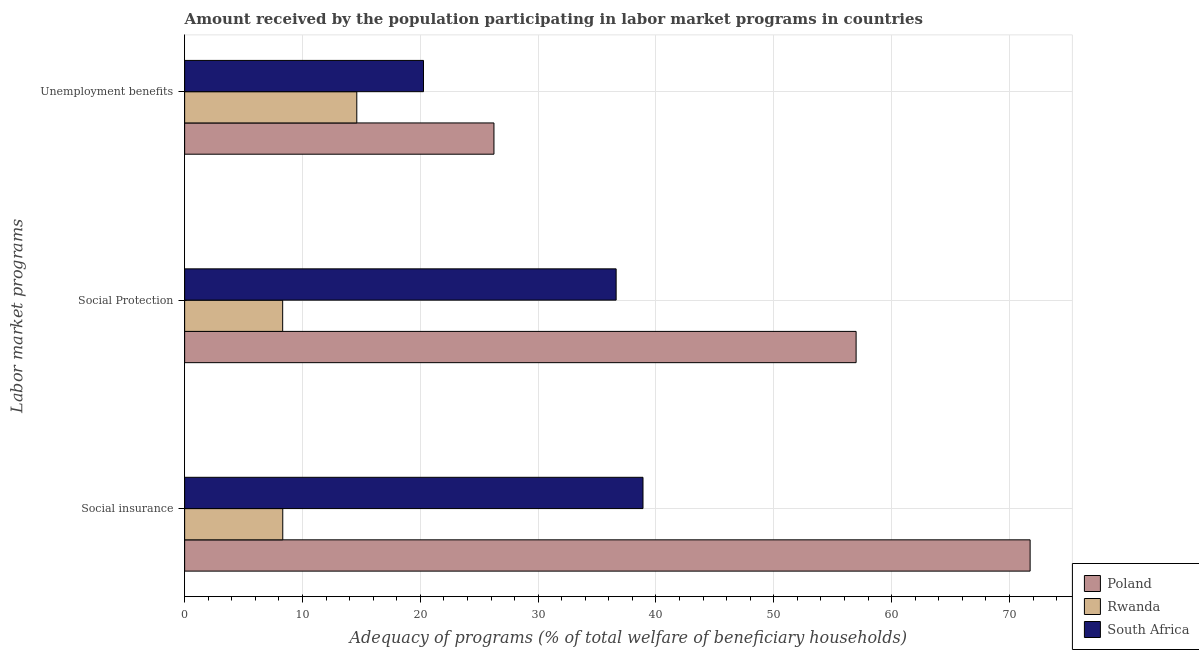Are the number of bars per tick equal to the number of legend labels?
Your response must be concise. Yes. Are the number of bars on each tick of the Y-axis equal?
Your response must be concise. Yes. What is the label of the 2nd group of bars from the top?
Provide a succinct answer. Social Protection. What is the amount received by the population participating in social insurance programs in South Africa?
Make the answer very short. 38.9. Across all countries, what is the maximum amount received by the population participating in unemployment benefits programs?
Ensure brevity in your answer.  26.25. Across all countries, what is the minimum amount received by the population participating in social protection programs?
Your response must be concise. 8.32. In which country was the amount received by the population participating in unemployment benefits programs maximum?
Offer a terse response. Poland. In which country was the amount received by the population participating in social insurance programs minimum?
Keep it short and to the point. Rwanda. What is the total amount received by the population participating in social insurance programs in the graph?
Give a very brief answer. 118.98. What is the difference between the amount received by the population participating in social insurance programs in South Africa and that in Poland?
Your answer should be very brief. -32.85. What is the difference between the amount received by the population participating in social insurance programs in Poland and the amount received by the population participating in social protection programs in South Africa?
Offer a very short reply. 35.13. What is the average amount received by the population participating in unemployment benefits programs per country?
Make the answer very short. 20.38. What is the difference between the amount received by the population participating in social protection programs and amount received by the population participating in unemployment benefits programs in South Africa?
Your answer should be very brief. 16.35. In how many countries, is the amount received by the population participating in social insurance programs greater than 24 %?
Your response must be concise. 2. What is the ratio of the amount received by the population participating in social insurance programs in South Africa to that in Rwanda?
Keep it short and to the point. 4.67. Is the amount received by the population participating in social protection programs in Poland less than that in Rwanda?
Your answer should be compact. No. What is the difference between the highest and the second highest amount received by the population participating in social protection programs?
Make the answer very short. 20.36. What is the difference between the highest and the lowest amount received by the population participating in social protection programs?
Ensure brevity in your answer.  48.67. In how many countries, is the amount received by the population participating in social insurance programs greater than the average amount received by the population participating in social insurance programs taken over all countries?
Make the answer very short. 1. Is the sum of the amount received by the population participating in unemployment benefits programs in Poland and South Africa greater than the maximum amount received by the population participating in social insurance programs across all countries?
Your response must be concise. No. What does the 1st bar from the top in Social Protection represents?
Offer a terse response. South Africa. Are the values on the major ticks of X-axis written in scientific E-notation?
Your answer should be very brief. No. What is the title of the graph?
Your answer should be compact. Amount received by the population participating in labor market programs in countries. Does "Bhutan" appear as one of the legend labels in the graph?
Keep it short and to the point. No. What is the label or title of the X-axis?
Make the answer very short. Adequacy of programs (% of total welfare of beneficiary households). What is the label or title of the Y-axis?
Keep it short and to the point. Labor market programs. What is the Adequacy of programs (% of total welfare of beneficiary households) of Poland in Social insurance?
Offer a very short reply. 71.75. What is the Adequacy of programs (% of total welfare of beneficiary households) in Rwanda in Social insurance?
Ensure brevity in your answer.  8.33. What is the Adequacy of programs (% of total welfare of beneficiary households) in South Africa in Social insurance?
Give a very brief answer. 38.9. What is the Adequacy of programs (% of total welfare of beneficiary households) in Poland in Social Protection?
Provide a succinct answer. 56.99. What is the Adequacy of programs (% of total welfare of beneficiary households) of Rwanda in Social Protection?
Provide a short and direct response. 8.32. What is the Adequacy of programs (% of total welfare of beneficiary households) of South Africa in Social Protection?
Provide a succinct answer. 36.62. What is the Adequacy of programs (% of total welfare of beneficiary households) in Poland in Unemployment benefits?
Make the answer very short. 26.25. What is the Adequacy of programs (% of total welfare of beneficiary households) of Rwanda in Unemployment benefits?
Give a very brief answer. 14.61. What is the Adequacy of programs (% of total welfare of beneficiary households) in South Africa in Unemployment benefits?
Ensure brevity in your answer.  20.27. Across all Labor market programs, what is the maximum Adequacy of programs (% of total welfare of beneficiary households) of Poland?
Keep it short and to the point. 71.75. Across all Labor market programs, what is the maximum Adequacy of programs (% of total welfare of beneficiary households) in Rwanda?
Offer a very short reply. 14.61. Across all Labor market programs, what is the maximum Adequacy of programs (% of total welfare of beneficiary households) in South Africa?
Provide a short and direct response. 38.9. Across all Labor market programs, what is the minimum Adequacy of programs (% of total welfare of beneficiary households) in Poland?
Give a very brief answer. 26.25. Across all Labor market programs, what is the minimum Adequacy of programs (% of total welfare of beneficiary households) in Rwanda?
Make the answer very short. 8.32. Across all Labor market programs, what is the minimum Adequacy of programs (% of total welfare of beneficiary households) in South Africa?
Offer a very short reply. 20.27. What is the total Adequacy of programs (% of total welfare of beneficiary households) of Poland in the graph?
Provide a short and direct response. 154.99. What is the total Adequacy of programs (% of total welfare of beneficiary households) in Rwanda in the graph?
Keep it short and to the point. 31.26. What is the total Adequacy of programs (% of total welfare of beneficiary households) of South Africa in the graph?
Your answer should be compact. 95.79. What is the difference between the Adequacy of programs (% of total welfare of beneficiary households) in Poland in Social insurance and that in Social Protection?
Provide a short and direct response. 14.77. What is the difference between the Adequacy of programs (% of total welfare of beneficiary households) in Rwanda in Social insurance and that in Social Protection?
Offer a very short reply. 0.01. What is the difference between the Adequacy of programs (% of total welfare of beneficiary households) in South Africa in Social insurance and that in Social Protection?
Make the answer very short. 2.28. What is the difference between the Adequacy of programs (% of total welfare of beneficiary households) of Poland in Social insurance and that in Unemployment benefits?
Provide a short and direct response. 45.5. What is the difference between the Adequacy of programs (% of total welfare of beneficiary households) of Rwanda in Social insurance and that in Unemployment benefits?
Your response must be concise. -6.28. What is the difference between the Adequacy of programs (% of total welfare of beneficiary households) in South Africa in Social insurance and that in Unemployment benefits?
Your answer should be compact. 18.63. What is the difference between the Adequacy of programs (% of total welfare of beneficiary households) in Poland in Social Protection and that in Unemployment benefits?
Give a very brief answer. 30.74. What is the difference between the Adequacy of programs (% of total welfare of beneficiary households) in Rwanda in Social Protection and that in Unemployment benefits?
Give a very brief answer. -6.29. What is the difference between the Adequacy of programs (% of total welfare of beneficiary households) of South Africa in Social Protection and that in Unemployment benefits?
Provide a succinct answer. 16.35. What is the difference between the Adequacy of programs (% of total welfare of beneficiary households) in Poland in Social insurance and the Adequacy of programs (% of total welfare of beneficiary households) in Rwanda in Social Protection?
Your answer should be compact. 63.43. What is the difference between the Adequacy of programs (% of total welfare of beneficiary households) of Poland in Social insurance and the Adequacy of programs (% of total welfare of beneficiary households) of South Africa in Social Protection?
Your answer should be very brief. 35.13. What is the difference between the Adequacy of programs (% of total welfare of beneficiary households) in Rwanda in Social insurance and the Adequacy of programs (% of total welfare of beneficiary households) in South Africa in Social Protection?
Give a very brief answer. -28.29. What is the difference between the Adequacy of programs (% of total welfare of beneficiary households) in Poland in Social insurance and the Adequacy of programs (% of total welfare of beneficiary households) in Rwanda in Unemployment benefits?
Your answer should be very brief. 57.14. What is the difference between the Adequacy of programs (% of total welfare of beneficiary households) in Poland in Social insurance and the Adequacy of programs (% of total welfare of beneficiary households) in South Africa in Unemployment benefits?
Your response must be concise. 51.48. What is the difference between the Adequacy of programs (% of total welfare of beneficiary households) of Rwanda in Social insurance and the Adequacy of programs (% of total welfare of beneficiary households) of South Africa in Unemployment benefits?
Your answer should be very brief. -11.94. What is the difference between the Adequacy of programs (% of total welfare of beneficiary households) of Poland in Social Protection and the Adequacy of programs (% of total welfare of beneficiary households) of Rwanda in Unemployment benefits?
Ensure brevity in your answer.  42.38. What is the difference between the Adequacy of programs (% of total welfare of beneficiary households) in Poland in Social Protection and the Adequacy of programs (% of total welfare of beneficiary households) in South Africa in Unemployment benefits?
Your answer should be very brief. 36.71. What is the difference between the Adequacy of programs (% of total welfare of beneficiary households) in Rwanda in Social Protection and the Adequacy of programs (% of total welfare of beneficiary households) in South Africa in Unemployment benefits?
Your response must be concise. -11.95. What is the average Adequacy of programs (% of total welfare of beneficiary households) in Poland per Labor market programs?
Offer a very short reply. 51.66. What is the average Adequacy of programs (% of total welfare of beneficiary households) in Rwanda per Labor market programs?
Offer a very short reply. 10.42. What is the average Adequacy of programs (% of total welfare of beneficiary households) in South Africa per Labor market programs?
Keep it short and to the point. 31.93. What is the difference between the Adequacy of programs (% of total welfare of beneficiary households) of Poland and Adequacy of programs (% of total welfare of beneficiary households) of Rwanda in Social insurance?
Your answer should be very brief. 63.43. What is the difference between the Adequacy of programs (% of total welfare of beneficiary households) in Poland and Adequacy of programs (% of total welfare of beneficiary households) in South Africa in Social insurance?
Your answer should be very brief. 32.85. What is the difference between the Adequacy of programs (% of total welfare of beneficiary households) of Rwanda and Adequacy of programs (% of total welfare of beneficiary households) of South Africa in Social insurance?
Keep it short and to the point. -30.57. What is the difference between the Adequacy of programs (% of total welfare of beneficiary households) in Poland and Adequacy of programs (% of total welfare of beneficiary households) in Rwanda in Social Protection?
Your answer should be compact. 48.67. What is the difference between the Adequacy of programs (% of total welfare of beneficiary households) of Poland and Adequacy of programs (% of total welfare of beneficiary households) of South Africa in Social Protection?
Make the answer very short. 20.36. What is the difference between the Adequacy of programs (% of total welfare of beneficiary households) in Rwanda and Adequacy of programs (% of total welfare of beneficiary households) in South Africa in Social Protection?
Provide a succinct answer. -28.3. What is the difference between the Adequacy of programs (% of total welfare of beneficiary households) of Poland and Adequacy of programs (% of total welfare of beneficiary households) of Rwanda in Unemployment benefits?
Ensure brevity in your answer.  11.64. What is the difference between the Adequacy of programs (% of total welfare of beneficiary households) of Poland and Adequacy of programs (% of total welfare of beneficiary households) of South Africa in Unemployment benefits?
Provide a short and direct response. 5.98. What is the difference between the Adequacy of programs (% of total welfare of beneficiary households) in Rwanda and Adequacy of programs (% of total welfare of beneficiary households) in South Africa in Unemployment benefits?
Your response must be concise. -5.66. What is the ratio of the Adequacy of programs (% of total welfare of beneficiary households) in Poland in Social insurance to that in Social Protection?
Make the answer very short. 1.26. What is the ratio of the Adequacy of programs (% of total welfare of beneficiary households) in Rwanda in Social insurance to that in Social Protection?
Ensure brevity in your answer.  1. What is the ratio of the Adequacy of programs (% of total welfare of beneficiary households) in South Africa in Social insurance to that in Social Protection?
Provide a short and direct response. 1.06. What is the ratio of the Adequacy of programs (% of total welfare of beneficiary households) in Poland in Social insurance to that in Unemployment benefits?
Keep it short and to the point. 2.73. What is the ratio of the Adequacy of programs (% of total welfare of beneficiary households) of Rwanda in Social insurance to that in Unemployment benefits?
Provide a succinct answer. 0.57. What is the ratio of the Adequacy of programs (% of total welfare of beneficiary households) in South Africa in Social insurance to that in Unemployment benefits?
Offer a very short reply. 1.92. What is the ratio of the Adequacy of programs (% of total welfare of beneficiary households) of Poland in Social Protection to that in Unemployment benefits?
Offer a terse response. 2.17. What is the ratio of the Adequacy of programs (% of total welfare of beneficiary households) of Rwanda in Social Protection to that in Unemployment benefits?
Your answer should be compact. 0.57. What is the ratio of the Adequacy of programs (% of total welfare of beneficiary households) of South Africa in Social Protection to that in Unemployment benefits?
Provide a short and direct response. 1.81. What is the difference between the highest and the second highest Adequacy of programs (% of total welfare of beneficiary households) of Poland?
Offer a very short reply. 14.77. What is the difference between the highest and the second highest Adequacy of programs (% of total welfare of beneficiary households) of Rwanda?
Offer a very short reply. 6.28. What is the difference between the highest and the second highest Adequacy of programs (% of total welfare of beneficiary households) in South Africa?
Make the answer very short. 2.28. What is the difference between the highest and the lowest Adequacy of programs (% of total welfare of beneficiary households) of Poland?
Keep it short and to the point. 45.5. What is the difference between the highest and the lowest Adequacy of programs (% of total welfare of beneficiary households) of Rwanda?
Provide a succinct answer. 6.29. What is the difference between the highest and the lowest Adequacy of programs (% of total welfare of beneficiary households) in South Africa?
Your answer should be compact. 18.63. 